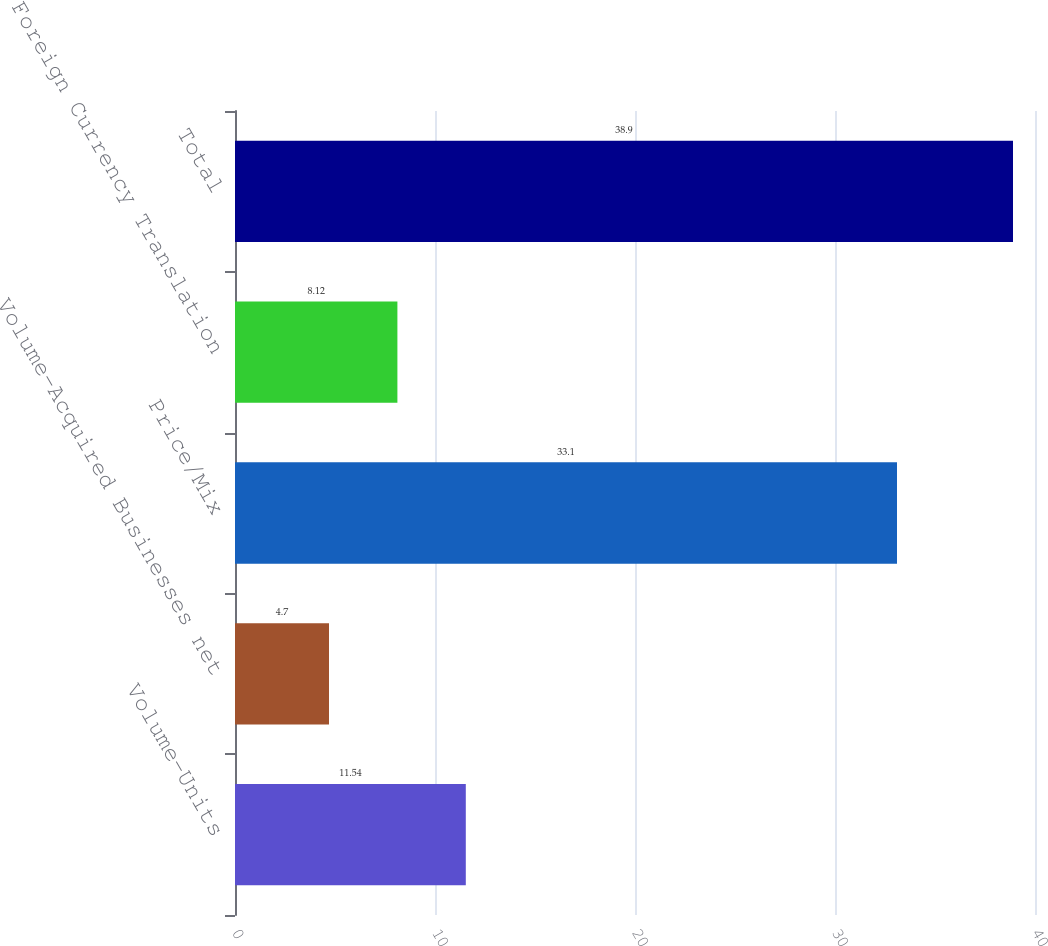Convert chart to OTSL. <chart><loc_0><loc_0><loc_500><loc_500><bar_chart><fcel>Volume-Units<fcel>Volume-Acquired Businesses net<fcel>Price/Mix<fcel>Foreign Currency Translation<fcel>Total<nl><fcel>11.54<fcel>4.7<fcel>33.1<fcel>8.12<fcel>38.9<nl></chart> 